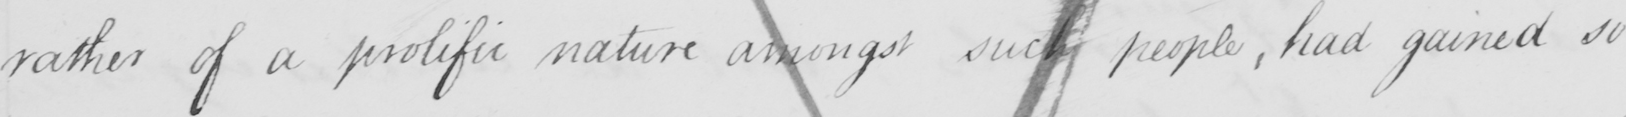Please provide the text content of this handwritten line. rather a prolific nature amongst such people, had gained so 